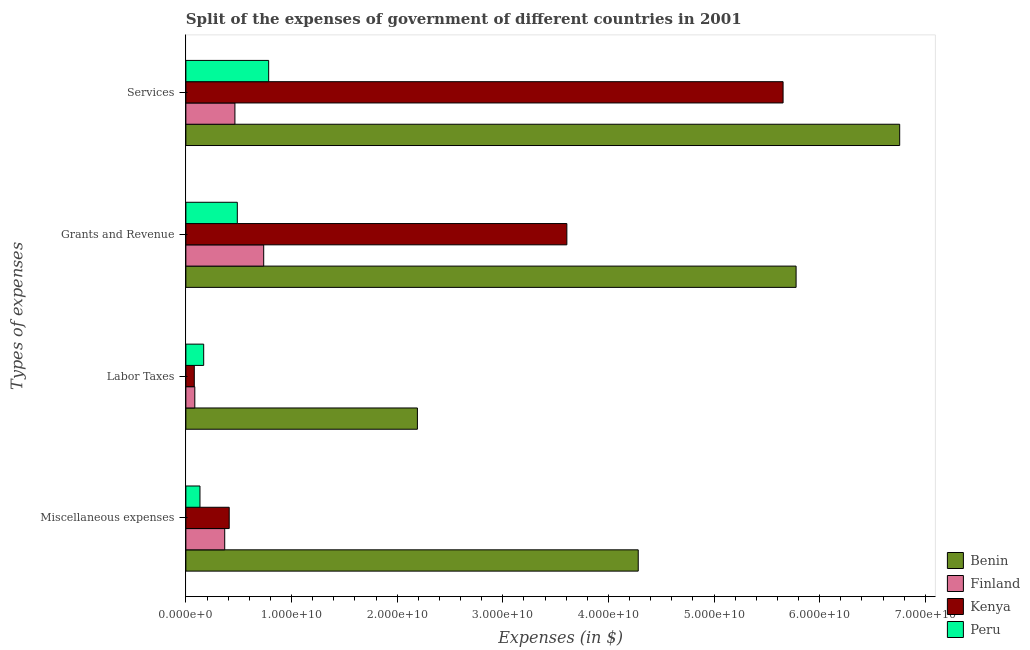How many different coloured bars are there?
Offer a very short reply. 4. How many groups of bars are there?
Give a very brief answer. 4. Are the number of bars on each tick of the Y-axis equal?
Your answer should be compact. Yes. How many bars are there on the 3rd tick from the bottom?
Ensure brevity in your answer.  4. What is the label of the 4th group of bars from the top?
Provide a short and direct response. Miscellaneous expenses. What is the amount spent on services in Finland?
Provide a short and direct response. 4.64e+09. Across all countries, what is the maximum amount spent on services?
Give a very brief answer. 6.76e+1. Across all countries, what is the minimum amount spent on labor taxes?
Your answer should be very brief. 7.97e+08. In which country was the amount spent on miscellaneous expenses maximum?
Your answer should be compact. Benin. In which country was the amount spent on grants and revenue minimum?
Keep it short and to the point. Peru. What is the total amount spent on labor taxes in the graph?
Your answer should be compact. 2.52e+1. What is the difference between the amount spent on labor taxes in Peru and that in Benin?
Provide a short and direct response. -2.02e+1. What is the difference between the amount spent on grants and revenue in Peru and the amount spent on services in Kenya?
Make the answer very short. -5.17e+1. What is the average amount spent on labor taxes per country?
Your response must be concise. 6.31e+09. What is the difference between the amount spent on miscellaneous expenses and amount spent on grants and revenue in Finland?
Make the answer very short. -3.69e+09. In how many countries, is the amount spent on miscellaneous expenses greater than 46000000000 $?
Your answer should be very brief. 0. What is the ratio of the amount spent on grants and revenue in Benin to that in Kenya?
Make the answer very short. 1.6. Is the difference between the amount spent on services in Peru and Benin greater than the difference between the amount spent on grants and revenue in Peru and Benin?
Your answer should be compact. No. What is the difference between the highest and the second highest amount spent on grants and revenue?
Keep it short and to the point. 2.17e+1. What is the difference between the highest and the lowest amount spent on miscellaneous expenses?
Your answer should be compact. 4.15e+1. In how many countries, is the amount spent on miscellaneous expenses greater than the average amount spent on miscellaneous expenses taken over all countries?
Ensure brevity in your answer.  1. Is the sum of the amount spent on labor taxes in Finland and Kenya greater than the maximum amount spent on miscellaneous expenses across all countries?
Your answer should be very brief. No. Is it the case that in every country, the sum of the amount spent on miscellaneous expenses and amount spent on labor taxes is greater than the sum of amount spent on services and amount spent on grants and revenue?
Give a very brief answer. No. What does the 4th bar from the top in Grants and Revenue represents?
Keep it short and to the point. Benin. What does the 1st bar from the bottom in Miscellaneous expenses represents?
Provide a succinct answer. Benin. How many bars are there?
Your response must be concise. 16. Are the values on the major ticks of X-axis written in scientific E-notation?
Offer a very short reply. Yes. Does the graph contain any zero values?
Provide a succinct answer. No. Where does the legend appear in the graph?
Provide a short and direct response. Bottom right. How many legend labels are there?
Your answer should be compact. 4. How are the legend labels stacked?
Provide a succinct answer. Vertical. What is the title of the graph?
Keep it short and to the point. Split of the expenses of government of different countries in 2001. What is the label or title of the X-axis?
Offer a terse response. Expenses (in $). What is the label or title of the Y-axis?
Give a very brief answer. Types of expenses. What is the Expenses (in $) in Benin in Miscellaneous expenses?
Make the answer very short. 4.28e+1. What is the Expenses (in $) in Finland in Miscellaneous expenses?
Offer a terse response. 3.68e+09. What is the Expenses (in $) in Kenya in Miscellaneous expenses?
Give a very brief answer. 4.10e+09. What is the Expenses (in $) in Peru in Miscellaneous expenses?
Offer a very short reply. 1.33e+09. What is the Expenses (in $) in Benin in Labor Taxes?
Provide a succinct answer. 2.19e+1. What is the Expenses (in $) of Finland in Labor Taxes?
Make the answer very short. 8.46e+08. What is the Expenses (in $) in Kenya in Labor Taxes?
Offer a very short reply. 7.97e+08. What is the Expenses (in $) in Peru in Labor Taxes?
Offer a terse response. 1.69e+09. What is the Expenses (in $) in Benin in Grants and Revenue?
Give a very brief answer. 5.78e+1. What is the Expenses (in $) of Finland in Grants and Revenue?
Provide a short and direct response. 7.37e+09. What is the Expenses (in $) in Kenya in Grants and Revenue?
Your response must be concise. 3.61e+1. What is the Expenses (in $) of Peru in Grants and Revenue?
Offer a terse response. 4.87e+09. What is the Expenses (in $) of Benin in Services?
Offer a very short reply. 6.76e+1. What is the Expenses (in $) of Finland in Services?
Offer a very short reply. 4.64e+09. What is the Expenses (in $) of Kenya in Services?
Give a very brief answer. 5.65e+1. What is the Expenses (in $) of Peru in Services?
Offer a terse response. 7.84e+09. Across all Types of expenses, what is the maximum Expenses (in $) of Benin?
Give a very brief answer. 6.76e+1. Across all Types of expenses, what is the maximum Expenses (in $) of Finland?
Give a very brief answer. 7.37e+09. Across all Types of expenses, what is the maximum Expenses (in $) of Kenya?
Your answer should be compact. 5.65e+1. Across all Types of expenses, what is the maximum Expenses (in $) in Peru?
Give a very brief answer. 7.84e+09. Across all Types of expenses, what is the minimum Expenses (in $) of Benin?
Make the answer very short. 2.19e+1. Across all Types of expenses, what is the minimum Expenses (in $) in Finland?
Give a very brief answer. 8.46e+08. Across all Types of expenses, what is the minimum Expenses (in $) of Kenya?
Ensure brevity in your answer.  7.97e+08. Across all Types of expenses, what is the minimum Expenses (in $) of Peru?
Offer a terse response. 1.33e+09. What is the total Expenses (in $) in Benin in the graph?
Provide a short and direct response. 1.90e+11. What is the total Expenses (in $) in Finland in the graph?
Give a very brief answer. 1.65e+1. What is the total Expenses (in $) of Kenya in the graph?
Keep it short and to the point. 9.75e+1. What is the total Expenses (in $) of Peru in the graph?
Make the answer very short. 1.57e+1. What is the difference between the Expenses (in $) in Benin in Miscellaneous expenses and that in Labor Taxes?
Your answer should be very brief. 2.09e+1. What is the difference between the Expenses (in $) in Finland in Miscellaneous expenses and that in Labor Taxes?
Give a very brief answer. 2.83e+09. What is the difference between the Expenses (in $) in Kenya in Miscellaneous expenses and that in Labor Taxes?
Keep it short and to the point. 3.31e+09. What is the difference between the Expenses (in $) in Peru in Miscellaneous expenses and that in Labor Taxes?
Keep it short and to the point. -3.52e+08. What is the difference between the Expenses (in $) of Benin in Miscellaneous expenses and that in Grants and Revenue?
Provide a short and direct response. -1.49e+1. What is the difference between the Expenses (in $) of Finland in Miscellaneous expenses and that in Grants and Revenue?
Make the answer very short. -3.69e+09. What is the difference between the Expenses (in $) in Kenya in Miscellaneous expenses and that in Grants and Revenue?
Ensure brevity in your answer.  -3.20e+1. What is the difference between the Expenses (in $) of Peru in Miscellaneous expenses and that in Grants and Revenue?
Your answer should be compact. -3.54e+09. What is the difference between the Expenses (in $) of Benin in Miscellaneous expenses and that in Services?
Your answer should be very brief. -2.48e+1. What is the difference between the Expenses (in $) of Finland in Miscellaneous expenses and that in Services?
Provide a succinct answer. -9.67e+08. What is the difference between the Expenses (in $) in Kenya in Miscellaneous expenses and that in Services?
Keep it short and to the point. -5.24e+1. What is the difference between the Expenses (in $) of Peru in Miscellaneous expenses and that in Services?
Your answer should be very brief. -6.50e+09. What is the difference between the Expenses (in $) in Benin in Labor Taxes and that in Grants and Revenue?
Give a very brief answer. -3.59e+1. What is the difference between the Expenses (in $) of Finland in Labor Taxes and that in Grants and Revenue?
Your response must be concise. -6.52e+09. What is the difference between the Expenses (in $) in Kenya in Labor Taxes and that in Grants and Revenue?
Offer a terse response. -3.53e+1. What is the difference between the Expenses (in $) of Peru in Labor Taxes and that in Grants and Revenue?
Your answer should be very brief. -3.18e+09. What is the difference between the Expenses (in $) in Benin in Labor Taxes and that in Services?
Provide a short and direct response. -4.57e+1. What is the difference between the Expenses (in $) of Finland in Labor Taxes and that in Services?
Provide a short and direct response. -3.80e+09. What is the difference between the Expenses (in $) in Kenya in Labor Taxes and that in Services?
Ensure brevity in your answer.  -5.57e+1. What is the difference between the Expenses (in $) in Peru in Labor Taxes and that in Services?
Give a very brief answer. -6.15e+09. What is the difference between the Expenses (in $) in Benin in Grants and Revenue and that in Services?
Offer a very short reply. -9.81e+09. What is the difference between the Expenses (in $) of Finland in Grants and Revenue and that in Services?
Offer a terse response. 2.72e+09. What is the difference between the Expenses (in $) of Kenya in Grants and Revenue and that in Services?
Give a very brief answer. -2.05e+1. What is the difference between the Expenses (in $) of Peru in Grants and Revenue and that in Services?
Keep it short and to the point. -2.97e+09. What is the difference between the Expenses (in $) in Benin in Miscellaneous expenses and the Expenses (in $) in Finland in Labor Taxes?
Provide a succinct answer. 4.20e+1. What is the difference between the Expenses (in $) of Benin in Miscellaneous expenses and the Expenses (in $) of Kenya in Labor Taxes?
Your answer should be very brief. 4.20e+1. What is the difference between the Expenses (in $) of Benin in Miscellaneous expenses and the Expenses (in $) of Peru in Labor Taxes?
Provide a short and direct response. 4.11e+1. What is the difference between the Expenses (in $) in Finland in Miscellaneous expenses and the Expenses (in $) in Kenya in Labor Taxes?
Offer a terse response. 2.88e+09. What is the difference between the Expenses (in $) of Finland in Miscellaneous expenses and the Expenses (in $) of Peru in Labor Taxes?
Your answer should be very brief. 1.99e+09. What is the difference between the Expenses (in $) of Kenya in Miscellaneous expenses and the Expenses (in $) of Peru in Labor Taxes?
Provide a succinct answer. 2.42e+09. What is the difference between the Expenses (in $) of Benin in Miscellaneous expenses and the Expenses (in $) of Finland in Grants and Revenue?
Provide a short and direct response. 3.55e+1. What is the difference between the Expenses (in $) in Benin in Miscellaneous expenses and the Expenses (in $) in Kenya in Grants and Revenue?
Give a very brief answer. 6.76e+09. What is the difference between the Expenses (in $) of Benin in Miscellaneous expenses and the Expenses (in $) of Peru in Grants and Revenue?
Give a very brief answer. 3.80e+1. What is the difference between the Expenses (in $) in Finland in Miscellaneous expenses and the Expenses (in $) in Kenya in Grants and Revenue?
Offer a very short reply. -3.24e+1. What is the difference between the Expenses (in $) of Finland in Miscellaneous expenses and the Expenses (in $) of Peru in Grants and Revenue?
Provide a succinct answer. -1.19e+09. What is the difference between the Expenses (in $) in Kenya in Miscellaneous expenses and the Expenses (in $) in Peru in Grants and Revenue?
Provide a succinct answer. -7.68e+08. What is the difference between the Expenses (in $) in Benin in Miscellaneous expenses and the Expenses (in $) in Finland in Services?
Give a very brief answer. 3.82e+1. What is the difference between the Expenses (in $) of Benin in Miscellaneous expenses and the Expenses (in $) of Kenya in Services?
Your response must be concise. -1.37e+1. What is the difference between the Expenses (in $) in Benin in Miscellaneous expenses and the Expenses (in $) in Peru in Services?
Offer a very short reply. 3.50e+1. What is the difference between the Expenses (in $) of Finland in Miscellaneous expenses and the Expenses (in $) of Kenya in Services?
Offer a terse response. -5.29e+1. What is the difference between the Expenses (in $) in Finland in Miscellaneous expenses and the Expenses (in $) in Peru in Services?
Give a very brief answer. -4.16e+09. What is the difference between the Expenses (in $) of Kenya in Miscellaneous expenses and the Expenses (in $) of Peru in Services?
Your answer should be very brief. -3.74e+09. What is the difference between the Expenses (in $) of Benin in Labor Taxes and the Expenses (in $) of Finland in Grants and Revenue?
Keep it short and to the point. 1.46e+1. What is the difference between the Expenses (in $) of Benin in Labor Taxes and the Expenses (in $) of Kenya in Grants and Revenue?
Ensure brevity in your answer.  -1.41e+1. What is the difference between the Expenses (in $) of Benin in Labor Taxes and the Expenses (in $) of Peru in Grants and Revenue?
Your answer should be very brief. 1.71e+1. What is the difference between the Expenses (in $) of Finland in Labor Taxes and the Expenses (in $) of Kenya in Grants and Revenue?
Offer a very short reply. -3.52e+1. What is the difference between the Expenses (in $) of Finland in Labor Taxes and the Expenses (in $) of Peru in Grants and Revenue?
Offer a terse response. -4.02e+09. What is the difference between the Expenses (in $) of Kenya in Labor Taxes and the Expenses (in $) of Peru in Grants and Revenue?
Give a very brief answer. -4.07e+09. What is the difference between the Expenses (in $) in Benin in Labor Taxes and the Expenses (in $) in Finland in Services?
Your answer should be compact. 1.73e+1. What is the difference between the Expenses (in $) of Benin in Labor Taxes and the Expenses (in $) of Kenya in Services?
Your response must be concise. -3.46e+1. What is the difference between the Expenses (in $) in Benin in Labor Taxes and the Expenses (in $) in Peru in Services?
Provide a succinct answer. 1.41e+1. What is the difference between the Expenses (in $) in Finland in Labor Taxes and the Expenses (in $) in Kenya in Services?
Give a very brief answer. -5.57e+1. What is the difference between the Expenses (in $) of Finland in Labor Taxes and the Expenses (in $) of Peru in Services?
Make the answer very short. -6.99e+09. What is the difference between the Expenses (in $) of Kenya in Labor Taxes and the Expenses (in $) of Peru in Services?
Provide a succinct answer. -7.04e+09. What is the difference between the Expenses (in $) of Benin in Grants and Revenue and the Expenses (in $) of Finland in Services?
Provide a short and direct response. 5.31e+1. What is the difference between the Expenses (in $) in Benin in Grants and Revenue and the Expenses (in $) in Kenya in Services?
Offer a terse response. 1.23e+09. What is the difference between the Expenses (in $) of Benin in Grants and Revenue and the Expenses (in $) of Peru in Services?
Make the answer very short. 4.99e+1. What is the difference between the Expenses (in $) of Finland in Grants and Revenue and the Expenses (in $) of Kenya in Services?
Make the answer very short. -4.92e+1. What is the difference between the Expenses (in $) in Finland in Grants and Revenue and the Expenses (in $) in Peru in Services?
Ensure brevity in your answer.  -4.70e+08. What is the difference between the Expenses (in $) of Kenya in Grants and Revenue and the Expenses (in $) of Peru in Services?
Offer a very short reply. 2.82e+1. What is the average Expenses (in $) in Benin per Types of expenses?
Give a very brief answer. 4.75e+1. What is the average Expenses (in $) of Finland per Types of expenses?
Provide a short and direct response. 4.13e+09. What is the average Expenses (in $) in Kenya per Types of expenses?
Ensure brevity in your answer.  2.44e+1. What is the average Expenses (in $) of Peru per Types of expenses?
Provide a short and direct response. 3.93e+09. What is the difference between the Expenses (in $) of Benin and Expenses (in $) of Finland in Miscellaneous expenses?
Your answer should be compact. 3.92e+1. What is the difference between the Expenses (in $) in Benin and Expenses (in $) in Kenya in Miscellaneous expenses?
Ensure brevity in your answer.  3.87e+1. What is the difference between the Expenses (in $) in Benin and Expenses (in $) in Peru in Miscellaneous expenses?
Provide a short and direct response. 4.15e+1. What is the difference between the Expenses (in $) of Finland and Expenses (in $) of Kenya in Miscellaneous expenses?
Give a very brief answer. -4.25e+08. What is the difference between the Expenses (in $) of Finland and Expenses (in $) of Peru in Miscellaneous expenses?
Offer a terse response. 2.34e+09. What is the difference between the Expenses (in $) in Kenya and Expenses (in $) in Peru in Miscellaneous expenses?
Keep it short and to the point. 2.77e+09. What is the difference between the Expenses (in $) of Benin and Expenses (in $) of Finland in Labor Taxes?
Provide a short and direct response. 2.11e+1. What is the difference between the Expenses (in $) of Benin and Expenses (in $) of Kenya in Labor Taxes?
Provide a short and direct response. 2.11e+1. What is the difference between the Expenses (in $) of Benin and Expenses (in $) of Peru in Labor Taxes?
Make the answer very short. 2.02e+1. What is the difference between the Expenses (in $) of Finland and Expenses (in $) of Kenya in Labor Taxes?
Offer a terse response. 4.94e+07. What is the difference between the Expenses (in $) of Finland and Expenses (in $) of Peru in Labor Taxes?
Give a very brief answer. -8.40e+08. What is the difference between the Expenses (in $) of Kenya and Expenses (in $) of Peru in Labor Taxes?
Keep it short and to the point. -8.89e+08. What is the difference between the Expenses (in $) in Benin and Expenses (in $) in Finland in Grants and Revenue?
Your answer should be very brief. 5.04e+1. What is the difference between the Expenses (in $) of Benin and Expenses (in $) of Kenya in Grants and Revenue?
Your answer should be very brief. 2.17e+1. What is the difference between the Expenses (in $) in Benin and Expenses (in $) in Peru in Grants and Revenue?
Offer a terse response. 5.29e+1. What is the difference between the Expenses (in $) of Finland and Expenses (in $) of Kenya in Grants and Revenue?
Your answer should be very brief. -2.87e+1. What is the difference between the Expenses (in $) in Finland and Expenses (in $) in Peru in Grants and Revenue?
Give a very brief answer. 2.50e+09. What is the difference between the Expenses (in $) in Kenya and Expenses (in $) in Peru in Grants and Revenue?
Keep it short and to the point. 3.12e+1. What is the difference between the Expenses (in $) of Benin and Expenses (in $) of Finland in Services?
Your answer should be compact. 6.29e+1. What is the difference between the Expenses (in $) in Benin and Expenses (in $) in Kenya in Services?
Keep it short and to the point. 1.10e+1. What is the difference between the Expenses (in $) in Benin and Expenses (in $) in Peru in Services?
Make the answer very short. 5.97e+1. What is the difference between the Expenses (in $) of Finland and Expenses (in $) of Kenya in Services?
Offer a very short reply. -5.19e+1. What is the difference between the Expenses (in $) in Finland and Expenses (in $) in Peru in Services?
Your response must be concise. -3.19e+09. What is the difference between the Expenses (in $) in Kenya and Expenses (in $) in Peru in Services?
Provide a short and direct response. 4.87e+1. What is the ratio of the Expenses (in $) of Benin in Miscellaneous expenses to that in Labor Taxes?
Make the answer very short. 1.95. What is the ratio of the Expenses (in $) of Finland in Miscellaneous expenses to that in Labor Taxes?
Offer a terse response. 4.35. What is the ratio of the Expenses (in $) of Kenya in Miscellaneous expenses to that in Labor Taxes?
Offer a very short reply. 5.15. What is the ratio of the Expenses (in $) in Peru in Miscellaneous expenses to that in Labor Taxes?
Your response must be concise. 0.79. What is the ratio of the Expenses (in $) in Benin in Miscellaneous expenses to that in Grants and Revenue?
Offer a very short reply. 0.74. What is the ratio of the Expenses (in $) of Finland in Miscellaneous expenses to that in Grants and Revenue?
Your answer should be very brief. 0.5. What is the ratio of the Expenses (in $) in Kenya in Miscellaneous expenses to that in Grants and Revenue?
Offer a terse response. 0.11. What is the ratio of the Expenses (in $) in Peru in Miscellaneous expenses to that in Grants and Revenue?
Provide a succinct answer. 0.27. What is the ratio of the Expenses (in $) in Benin in Miscellaneous expenses to that in Services?
Offer a very short reply. 0.63. What is the ratio of the Expenses (in $) in Finland in Miscellaneous expenses to that in Services?
Ensure brevity in your answer.  0.79. What is the ratio of the Expenses (in $) of Kenya in Miscellaneous expenses to that in Services?
Your response must be concise. 0.07. What is the ratio of the Expenses (in $) of Peru in Miscellaneous expenses to that in Services?
Provide a short and direct response. 0.17. What is the ratio of the Expenses (in $) in Benin in Labor Taxes to that in Grants and Revenue?
Provide a succinct answer. 0.38. What is the ratio of the Expenses (in $) in Finland in Labor Taxes to that in Grants and Revenue?
Your answer should be compact. 0.11. What is the ratio of the Expenses (in $) in Kenya in Labor Taxes to that in Grants and Revenue?
Provide a succinct answer. 0.02. What is the ratio of the Expenses (in $) in Peru in Labor Taxes to that in Grants and Revenue?
Ensure brevity in your answer.  0.35. What is the ratio of the Expenses (in $) of Benin in Labor Taxes to that in Services?
Offer a terse response. 0.32. What is the ratio of the Expenses (in $) in Finland in Labor Taxes to that in Services?
Ensure brevity in your answer.  0.18. What is the ratio of the Expenses (in $) in Kenya in Labor Taxes to that in Services?
Provide a short and direct response. 0.01. What is the ratio of the Expenses (in $) of Peru in Labor Taxes to that in Services?
Offer a very short reply. 0.22. What is the ratio of the Expenses (in $) of Benin in Grants and Revenue to that in Services?
Keep it short and to the point. 0.85. What is the ratio of the Expenses (in $) of Finland in Grants and Revenue to that in Services?
Provide a succinct answer. 1.59. What is the ratio of the Expenses (in $) in Kenya in Grants and Revenue to that in Services?
Ensure brevity in your answer.  0.64. What is the ratio of the Expenses (in $) in Peru in Grants and Revenue to that in Services?
Offer a very short reply. 0.62. What is the difference between the highest and the second highest Expenses (in $) in Benin?
Offer a terse response. 9.81e+09. What is the difference between the highest and the second highest Expenses (in $) in Finland?
Offer a terse response. 2.72e+09. What is the difference between the highest and the second highest Expenses (in $) of Kenya?
Your response must be concise. 2.05e+1. What is the difference between the highest and the second highest Expenses (in $) in Peru?
Provide a succinct answer. 2.97e+09. What is the difference between the highest and the lowest Expenses (in $) of Benin?
Your response must be concise. 4.57e+1. What is the difference between the highest and the lowest Expenses (in $) of Finland?
Ensure brevity in your answer.  6.52e+09. What is the difference between the highest and the lowest Expenses (in $) in Kenya?
Give a very brief answer. 5.57e+1. What is the difference between the highest and the lowest Expenses (in $) in Peru?
Your answer should be compact. 6.50e+09. 